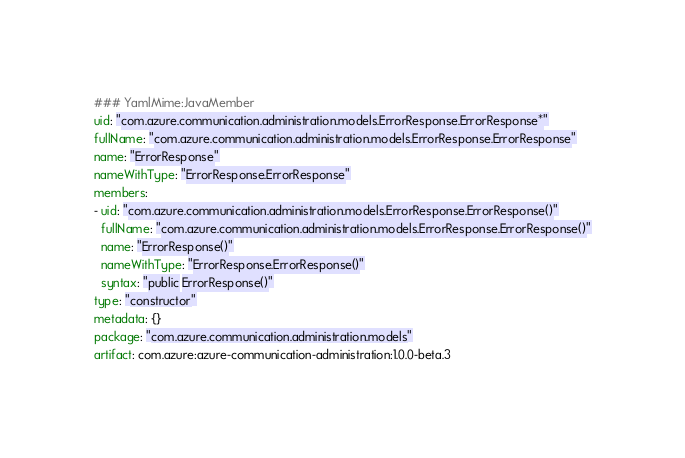Convert code to text. <code><loc_0><loc_0><loc_500><loc_500><_YAML_>### YamlMime:JavaMember
uid: "com.azure.communication.administration.models.ErrorResponse.ErrorResponse*"
fullName: "com.azure.communication.administration.models.ErrorResponse.ErrorResponse"
name: "ErrorResponse"
nameWithType: "ErrorResponse.ErrorResponse"
members:
- uid: "com.azure.communication.administration.models.ErrorResponse.ErrorResponse()"
  fullName: "com.azure.communication.administration.models.ErrorResponse.ErrorResponse()"
  name: "ErrorResponse()"
  nameWithType: "ErrorResponse.ErrorResponse()"
  syntax: "public ErrorResponse()"
type: "constructor"
metadata: {}
package: "com.azure.communication.administration.models"
artifact: com.azure:azure-communication-administration:1.0.0-beta.3
</code> 